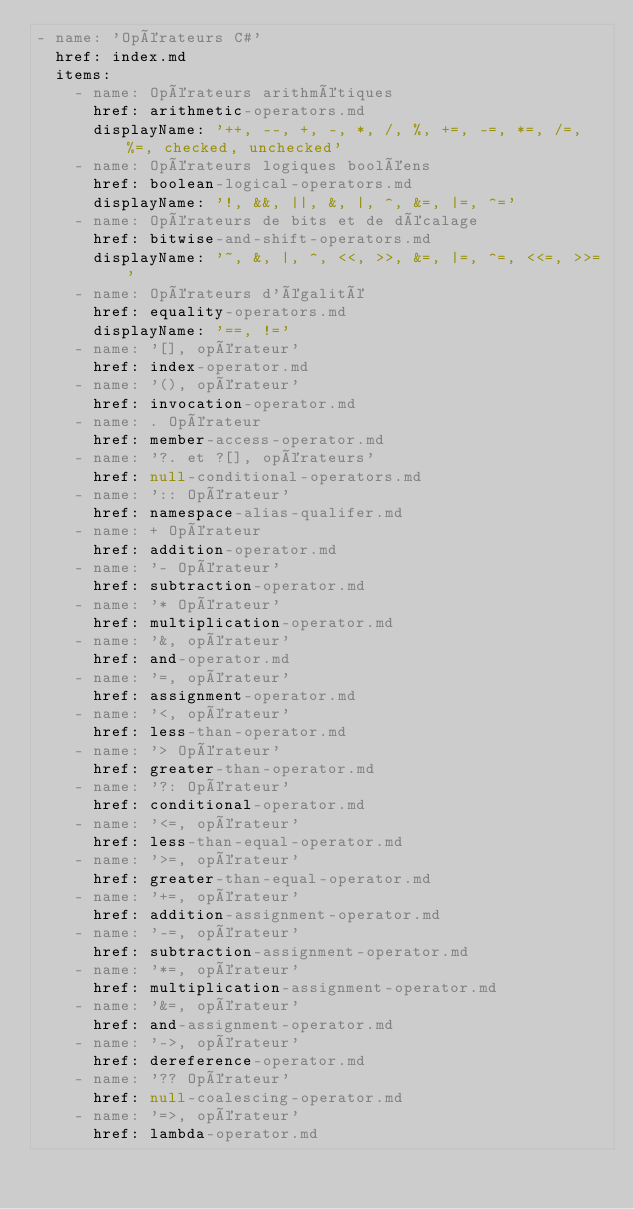Convert code to text. <code><loc_0><loc_0><loc_500><loc_500><_YAML_>- name: 'Opérateurs C#'
  href: index.md
  items:
    - name: Opérateurs arithmétiques
      href: arithmetic-operators.md
      displayName: '++, --, +, -, *, /, %, +=, -=, *=, /=, %=, checked, unchecked'
    - name: Opérateurs logiques booléens
      href: boolean-logical-operators.md
      displayName: '!, &&, ||, &, |, ^, &=, |=, ^='
    - name: Opérateurs de bits et de décalage
      href: bitwise-and-shift-operators.md
      displayName: '~, &, |, ^, <<, >>, &=, |=, ^=, <<=, >>='
    - name: Opérateurs d'égalité
      href: equality-operators.md
      displayName: '==, !='
    - name: '[], opérateur'
      href: index-operator.md
    - name: '(), opérateur'
      href: invocation-operator.md
    - name: . Opérateur
      href: member-access-operator.md
    - name: '?. et ?[], opérateurs'
      href: null-conditional-operators.md
    - name: ':: Opérateur'
      href: namespace-alias-qualifer.md
    - name: + Opérateur
      href: addition-operator.md
    - name: '- Opérateur'
      href: subtraction-operator.md
    - name: '* Opérateur'
      href: multiplication-operator.md
    - name: '&, opérateur'
      href: and-operator.md
    - name: '=, opérateur'
      href: assignment-operator.md
    - name: '<, opérateur'
      href: less-than-operator.md
    - name: '> Opérateur'
      href: greater-than-operator.md
    - name: '?: Opérateur'
      href: conditional-operator.md
    - name: '<=, opérateur'
      href: less-than-equal-operator.md
    - name: '>=, opérateur'
      href: greater-than-equal-operator.md
    - name: '+=, opérateur'
      href: addition-assignment-operator.md
    - name: '-=, opérateur'
      href: subtraction-assignment-operator.md
    - name: '*=, opérateur'
      href: multiplication-assignment-operator.md
    - name: '&=, opérateur'
      href: and-assignment-operator.md
    - name: '->, opérateur'
      href: dereference-operator.md
    - name: '?? Opérateur'
      href: null-coalescing-operator.md
    - name: '=>, opérateur'
      href: lambda-operator.md</code> 